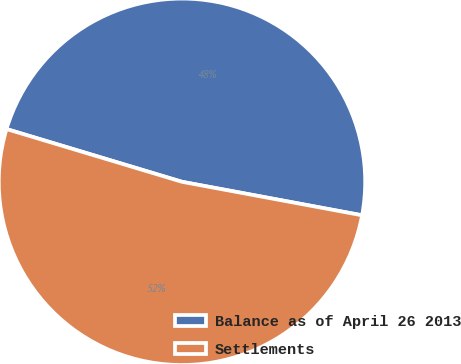Convert chart to OTSL. <chart><loc_0><loc_0><loc_500><loc_500><pie_chart><fcel>Balance as of April 26 2013<fcel>Settlements<nl><fcel>48.28%<fcel>51.72%<nl></chart> 